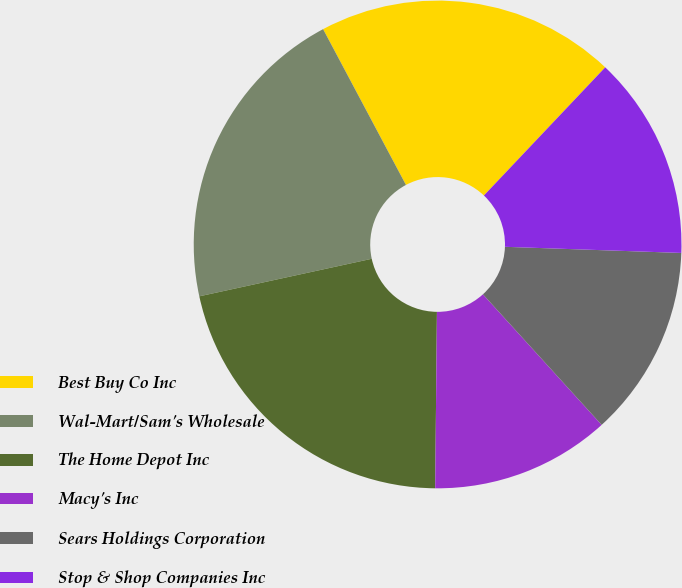Convert chart. <chart><loc_0><loc_0><loc_500><loc_500><pie_chart><fcel>Best Buy Co Inc<fcel>Wal-Mart/Sam's Wholesale<fcel>The Home Depot Inc<fcel>Macy's Inc<fcel>Sears Holdings Corporation<fcel>Stop & Shop Companies Inc<nl><fcel>19.84%<fcel>20.63%<fcel>21.43%<fcel>11.9%<fcel>12.7%<fcel>13.49%<nl></chart> 